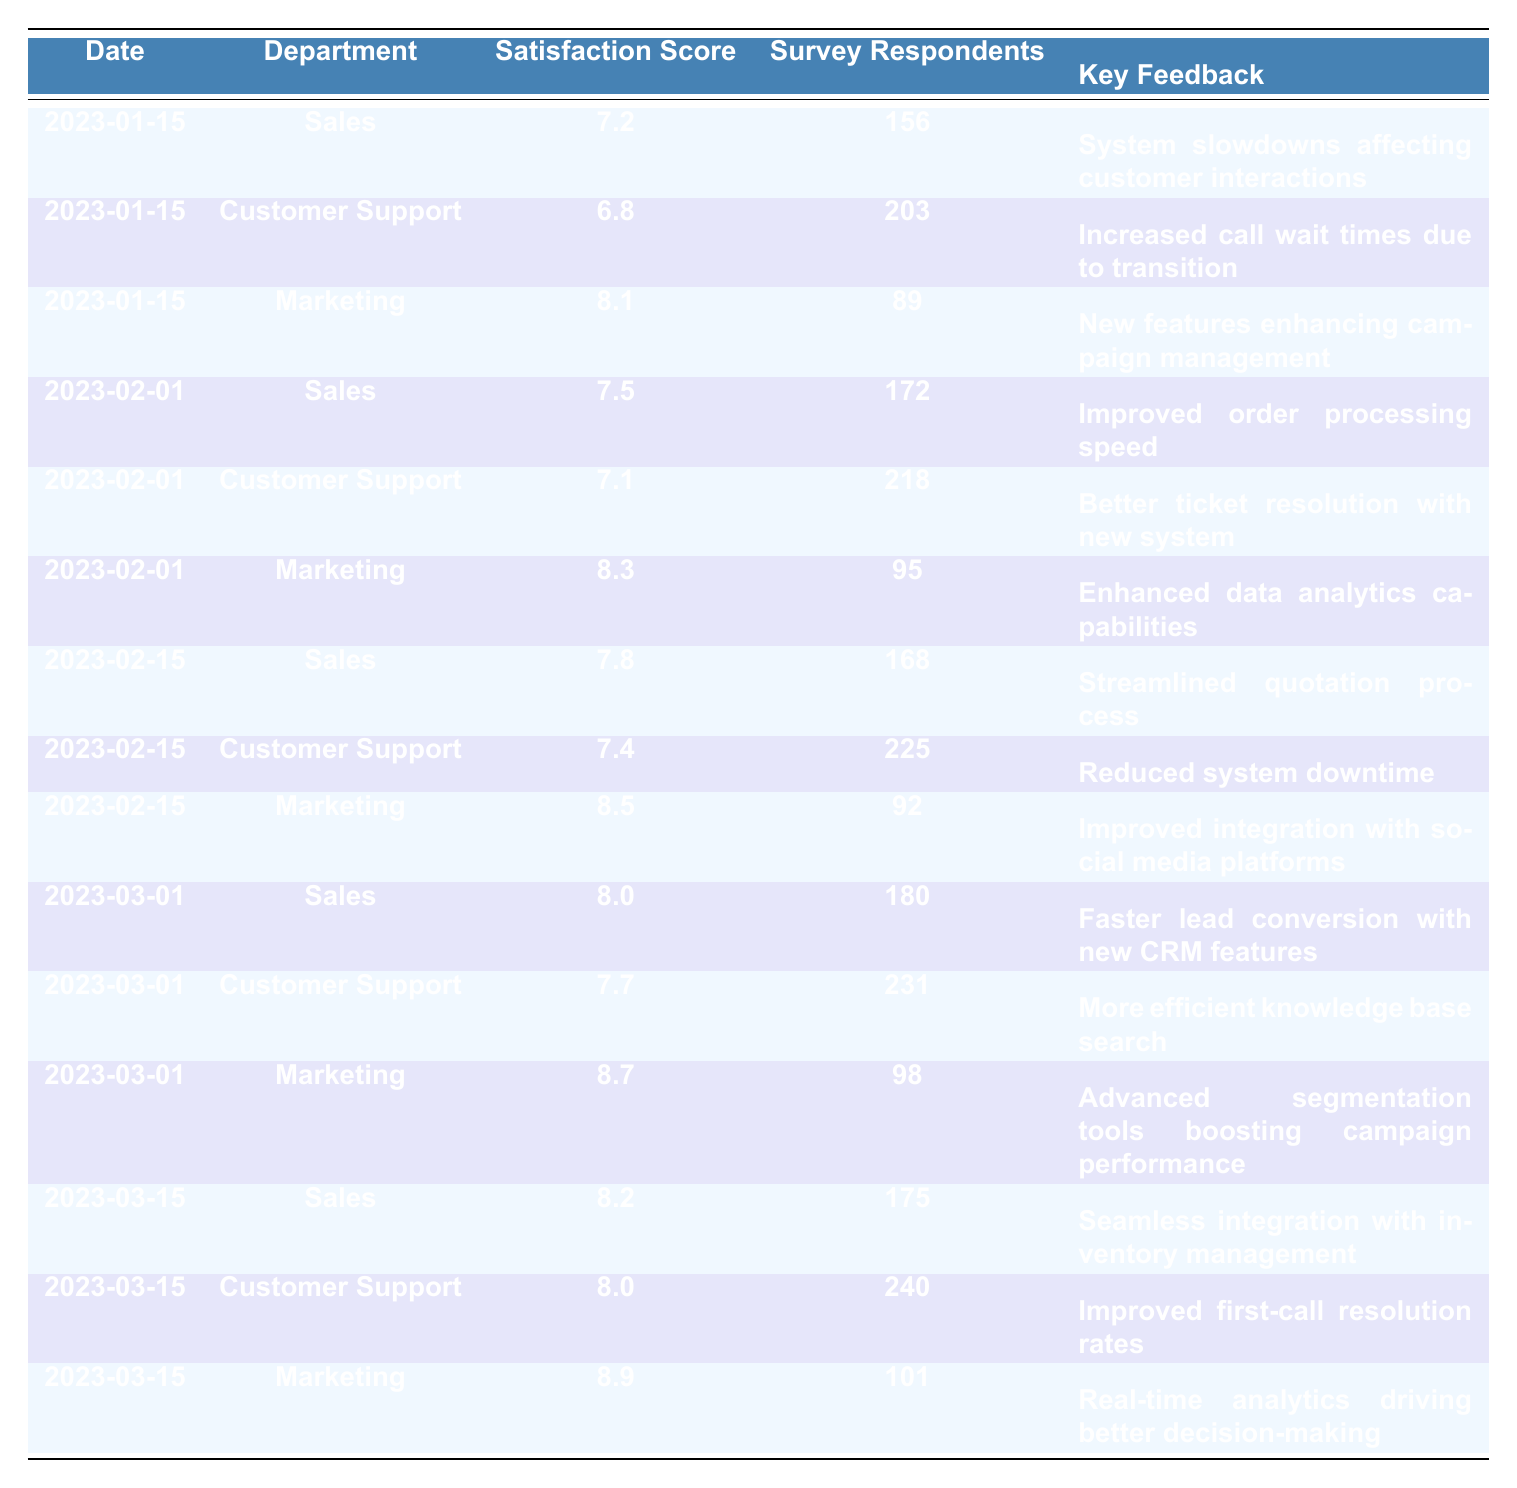What was the highest customer satisfaction score reported during the transition period? The highest satisfaction score in the table is 8.9, which is listed under the Marketing department on the date 2023-03-15.
Answer: 8.9 Which department had the lowest satisfaction score on 2023-01-15? On 2023-01-15, the Customer Support department had the lowest satisfaction score of 6.8 compared to Sales (7.2) and Marketing (8.1).
Answer: Customer Support What was the average satisfaction score for the Sales department across all recorded dates? The scores for Sales are 7.2, 7.5, 7.8, 8.0, and 8.2. Summing them gives 38.7 and dividing by 5 results in an average score of 7.74.
Answer: 7.74 Did the Customer Support department improve its satisfaction score from February 1 to February 15? On February 1, the score was 7.1, and on February 15, it increased to 7.4, indicating an improvement.
Answer: Yes What was the key feedback from Marketing on 2023-02-15? On that date, the key feedback reported by the Marketing department was "Improved integration with social media platforms."
Answer: Improved integration with social media platforms What trend can be observed in the Customer Support satisfaction scores from January to March? The scores for Customer Support started at 6.8 in January, increased to 7.1 in February, then rose to 7.4 on February 15, and further improved to 8.0 by March 15, indicating a consistent upward trend.
Answer: Consistent upward trend Which department saw the most significant increase in satisfaction score from the first to the last date recorded? The Marketing department's score improved from 8.1 on 2023-01-15 to 8.9 on 2023-03-15. This is a difference of 0.8 points, which is the largest increase among all departments.
Answer: Marketing On which date did the Sales department first achieve a satisfaction score of 8 or higher? The Sales department first achieved a score of 8 or higher on 2023-03-01, where the score reached 8.0.
Answer: 2023-03-01 What was the total number of Survey Respondents for the Marketing department across all the recorded dates? The number of respondents for Marketing is 89 (2023-01-15), 95 (2023-02-01), 92 (2023-02-15), 98 (2023-03-01), and 101 (2023-03-15). Adding these numbers gives 475.
Answer: 475 Was there any feedback indicating reduced system issues in any department during February? Yes, on February 15, the Customer Support department mentioned "Reduced system downtime," indicating a positive feedback regarding system issues during that month.
Answer: Yes 